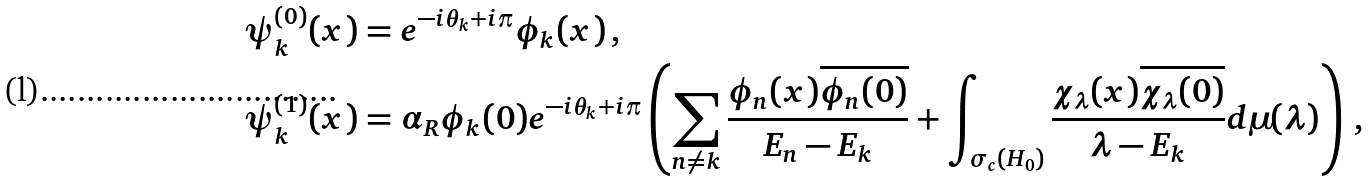Convert formula to latex. <formula><loc_0><loc_0><loc_500><loc_500>\psi _ { k } ^ { ( 0 ) } ( x ) & = e ^ { - i \theta _ { k } + i \pi } \phi _ { k } ( x ) \, , \\ \psi _ { k } ^ { ( 1 ) } ( x ) & = \alpha _ { R } \phi _ { k } ( 0 ) e ^ { - i \theta _ { k } + i \pi } \left ( \sum _ { n \neq k } \frac { \phi _ { n } ( x ) \overline { \phi _ { n } ( 0 ) } } { E _ { n } - E _ { k } } + \int _ { \sigma _ { c } ( H _ { 0 } ) } \frac { \chi _ { \lambda } ( x ) \overline { \chi _ { \lambda } ( 0 ) } } { \lambda - E _ { k } } d \mu ( \lambda ) \right ) \, ,</formula> 